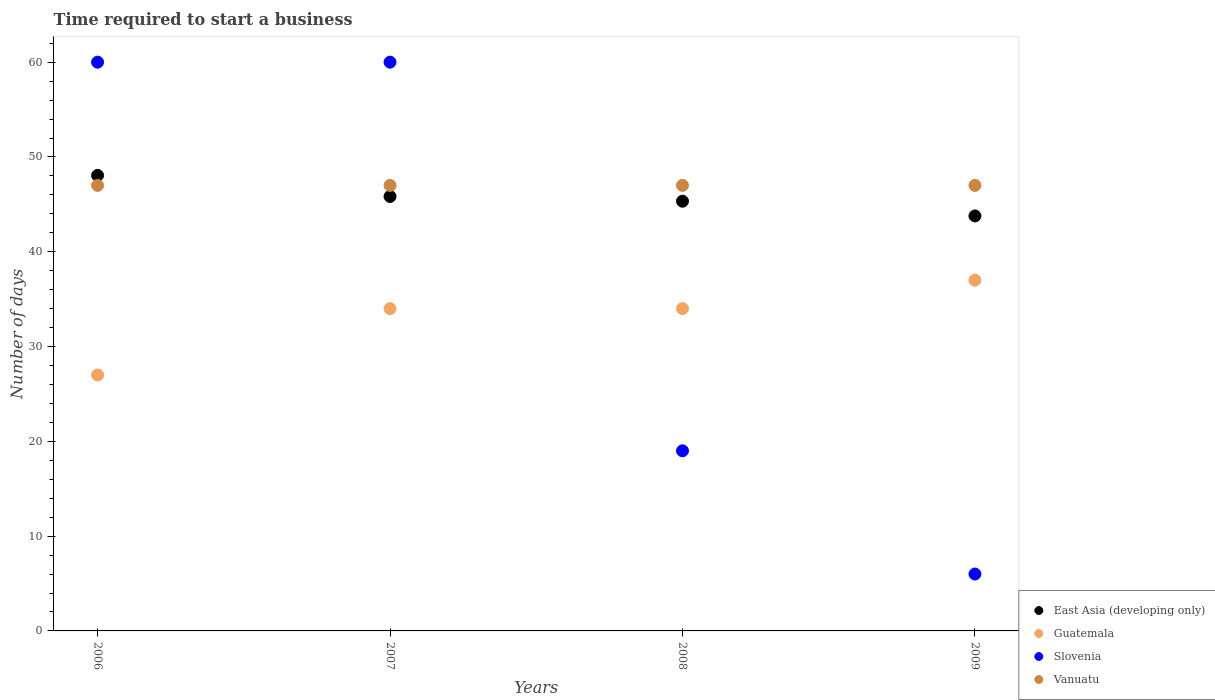Across all years, what is the maximum number of days required to start a business in East Asia (developing only)?
Provide a succinct answer. 48.06. Across all years, what is the minimum number of days required to start a business in East Asia (developing only)?
Provide a succinct answer. 43.78. In which year was the number of days required to start a business in East Asia (developing only) maximum?
Make the answer very short. 2006. What is the total number of days required to start a business in Slovenia in the graph?
Make the answer very short. 145. What is the difference between the number of days required to start a business in Vanuatu in 2006 and the number of days required to start a business in East Asia (developing only) in 2008?
Ensure brevity in your answer.  1.67. In the year 2007, what is the difference between the number of days required to start a business in East Asia (developing only) and number of days required to start a business in Vanuatu?
Make the answer very short. -1.17. What is the ratio of the number of days required to start a business in Slovenia in 2007 to that in 2008?
Your response must be concise. 3.16. Is the number of days required to start a business in Guatemala in 2006 less than that in 2007?
Your answer should be very brief. Yes. What is the difference between the highest and the second highest number of days required to start a business in East Asia (developing only)?
Make the answer very short. 2.22. In how many years, is the number of days required to start a business in Vanuatu greater than the average number of days required to start a business in Vanuatu taken over all years?
Offer a very short reply. 0. Is the sum of the number of days required to start a business in Guatemala in 2007 and 2008 greater than the maximum number of days required to start a business in East Asia (developing only) across all years?
Offer a terse response. Yes. Is it the case that in every year, the sum of the number of days required to start a business in Slovenia and number of days required to start a business in Vanuatu  is greater than the number of days required to start a business in East Asia (developing only)?
Your response must be concise. Yes. How many dotlines are there?
Keep it short and to the point. 4. Are the values on the major ticks of Y-axis written in scientific E-notation?
Provide a short and direct response. No. Does the graph contain any zero values?
Give a very brief answer. No. Where does the legend appear in the graph?
Keep it short and to the point. Bottom right. How many legend labels are there?
Offer a very short reply. 4. How are the legend labels stacked?
Your answer should be compact. Vertical. What is the title of the graph?
Offer a terse response. Time required to start a business. What is the label or title of the X-axis?
Ensure brevity in your answer.  Years. What is the label or title of the Y-axis?
Offer a terse response. Number of days. What is the Number of days in East Asia (developing only) in 2006?
Your answer should be very brief. 48.06. What is the Number of days in Slovenia in 2006?
Your answer should be very brief. 60. What is the Number of days in East Asia (developing only) in 2007?
Provide a short and direct response. 45.83. What is the Number of days of Vanuatu in 2007?
Your answer should be very brief. 47. What is the Number of days in East Asia (developing only) in 2008?
Your answer should be very brief. 45.33. What is the Number of days of Vanuatu in 2008?
Your answer should be compact. 47. What is the Number of days of East Asia (developing only) in 2009?
Offer a very short reply. 43.78. What is the Number of days of Guatemala in 2009?
Your answer should be compact. 37. What is the Number of days in Vanuatu in 2009?
Give a very brief answer. 47. Across all years, what is the maximum Number of days of East Asia (developing only)?
Ensure brevity in your answer.  48.06. Across all years, what is the maximum Number of days in Guatemala?
Provide a succinct answer. 37. Across all years, what is the maximum Number of days in Slovenia?
Offer a terse response. 60. Across all years, what is the minimum Number of days in East Asia (developing only)?
Your answer should be compact. 43.78. Across all years, what is the minimum Number of days in Slovenia?
Offer a terse response. 6. What is the total Number of days in East Asia (developing only) in the graph?
Keep it short and to the point. 183. What is the total Number of days of Guatemala in the graph?
Ensure brevity in your answer.  132. What is the total Number of days in Slovenia in the graph?
Keep it short and to the point. 145. What is the total Number of days of Vanuatu in the graph?
Your answer should be compact. 188. What is the difference between the Number of days in East Asia (developing only) in 2006 and that in 2007?
Offer a terse response. 2.22. What is the difference between the Number of days of Guatemala in 2006 and that in 2007?
Keep it short and to the point. -7. What is the difference between the Number of days of Slovenia in 2006 and that in 2007?
Make the answer very short. 0. What is the difference between the Number of days in East Asia (developing only) in 2006 and that in 2008?
Offer a very short reply. 2.72. What is the difference between the Number of days in Guatemala in 2006 and that in 2008?
Offer a terse response. -7. What is the difference between the Number of days in Vanuatu in 2006 and that in 2008?
Your answer should be compact. 0. What is the difference between the Number of days of East Asia (developing only) in 2006 and that in 2009?
Give a very brief answer. 4.28. What is the difference between the Number of days of Guatemala in 2006 and that in 2009?
Provide a succinct answer. -10. What is the difference between the Number of days of East Asia (developing only) in 2007 and that in 2008?
Ensure brevity in your answer.  0.5. What is the difference between the Number of days of East Asia (developing only) in 2007 and that in 2009?
Offer a very short reply. 2.06. What is the difference between the Number of days in Guatemala in 2007 and that in 2009?
Offer a very short reply. -3. What is the difference between the Number of days in East Asia (developing only) in 2008 and that in 2009?
Offer a terse response. 1.56. What is the difference between the Number of days in Guatemala in 2008 and that in 2009?
Offer a terse response. -3. What is the difference between the Number of days in Slovenia in 2008 and that in 2009?
Offer a terse response. 13. What is the difference between the Number of days of East Asia (developing only) in 2006 and the Number of days of Guatemala in 2007?
Provide a short and direct response. 14.06. What is the difference between the Number of days in East Asia (developing only) in 2006 and the Number of days in Slovenia in 2007?
Provide a short and direct response. -11.94. What is the difference between the Number of days of East Asia (developing only) in 2006 and the Number of days of Vanuatu in 2007?
Keep it short and to the point. 1.06. What is the difference between the Number of days in Guatemala in 2006 and the Number of days in Slovenia in 2007?
Give a very brief answer. -33. What is the difference between the Number of days in Guatemala in 2006 and the Number of days in Vanuatu in 2007?
Make the answer very short. -20. What is the difference between the Number of days in East Asia (developing only) in 2006 and the Number of days in Guatemala in 2008?
Give a very brief answer. 14.06. What is the difference between the Number of days of East Asia (developing only) in 2006 and the Number of days of Slovenia in 2008?
Make the answer very short. 29.06. What is the difference between the Number of days of East Asia (developing only) in 2006 and the Number of days of Vanuatu in 2008?
Offer a very short reply. 1.06. What is the difference between the Number of days in Guatemala in 2006 and the Number of days in Slovenia in 2008?
Offer a very short reply. 8. What is the difference between the Number of days in Slovenia in 2006 and the Number of days in Vanuatu in 2008?
Your answer should be very brief. 13. What is the difference between the Number of days in East Asia (developing only) in 2006 and the Number of days in Guatemala in 2009?
Your answer should be very brief. 11.06. What is the difference between the Number of days in East Asia (developing only) in 2006 and the Number of days in Slovenia in 2009?
Your response must be concise. 42.06. What is the difference between the Number of days in East Asia (developing only) in 2006 and the Number of days in Vanuatu in 2009?
Your response must be concise. 1.06. What is the difference between the Number of days in Guatemala in 2006 and the Number of days in Vanuatu in 2009?
Provide a short and direct response. -20. What is the difference between the Number of days in East Asia (developing only) in 2007 and the Number of days in Guatemala in 2008?
Your answer should be compact. 11.83. What is the difference between the Number of days of East Asia (developing only) in 2007 and the Number of days of Slovenia in 2008?
Make the answer very short. 26.83. What is the difference between the Number of days in East Asia (developing only) in 2007 and the Number of days in Vanuatu in 2008?
Make the answer very short. -1.17. What is the difference between the Number of days of Guatemala in 2007 and the Number of days of Vanuatu in 2008?
Provide a short and direct response. -13. What is the difference between the Number of days in Slovenia in 2007 and the Number of days in Vanuatu in 2008?
Your answer should be compact. 13. What is the difference between the Number of days in East Asia (developing only) in 2007 and the Number of days in Guatemala in 2009?
Offer a very short reply. 8.83. What is the difference between the Number of days in East Asia (developing only) in 2007 and the Number of days in Slovenia in 2009?
Offer a very short reply. 39.83. What is the difference between the Number of days in East Asia (developing only) in 2007 and the Number of days in Vanuatu in 2009?
Your response must be concise. -1.17. What is the difference between the Number of days in Guatemala in 2007 and the Number of days in Vanuatu in 2009?
Give a very brief answer. -13. What is the difference between the Number of days in Slovenia in 2007 and the Number of days in Vanuatu in 2009?
Offer a very short reply. 13. What is the difference between the Number of days of East Asia (developing only) in 2008 and the Number of days of Guatemala in 2009?
Make the answer very short. 8.33. What is the difference between the Number of days in East Asia (developing only) in 2008 and the Number of days in Slovenia in 2009?
Keep it short and to the point. 39.33. What is the difference between the Number of days in East Asia (developing only) in 2008 and the Number of days in Vanuatu in 2009?
Offer a very short reply. -1.67. What is the difference between the Number of days in Guatemala in 2008 and the Number of days in Slovenia in 2009?
Give a very brief answer. 28. What is the difference between the Number of days in Guatemala in 2008 and the Number of days in Vanuatu in 2009?
Give a very brief answer. -13. What is the average Number of days in East Asia (developing only) per year?
Your answer should be compact. 45.75. What is the average Number of days in Guatemala per year?
Provide a succinct answer. 33. What is the average Number of days in Slovenia per year?
Provide a succinct answer. 36.25. What is the average Number of days in Vanuatu per year?
Your answer should be compact. 47. In the year 2006, what is the difference between the Number of days of East Asia (developing only) and Number of days of Guatemala?
Provide a short and direct response. 21.06. In the year 2006, what is the difference between the Number of days in East Asia (developing only) and Number of days in Slovenia?
Offer a terse response. -11.94. In the year 2006, what is the difference between the Number of days of East Asia (developing only) and Number of days of Vanuatu?
Ensure brevity in your answer.  1.06. In the year 2006, what is the difference between the Number of days in Guatemala and Number of days in Slovenia?
Ensure brevity in your answer.  -33. In the year 2006, what is the difference between the Number of days of Guatemala and Number of days of Vanuatu?
Keep it short and to the point. -20. In the year 2006, what is the difference between the Number of days in Slovenia and Number of days in Vanuatu?
Make the answer very short. 13. In the year 2007, what is the difference between the Number of days of East Asia (developing only) and Number of days of Guatemala?
Your answer should be compact. 11.83. In the year 2007, what is the difference between the Number of days of East Asia (developing only) and Number of days of Slovenia?
Offer a terse response. -14.17. In the year 2007, what is the difference between the Number of days of East Asia (developing only) and Number of days of Vanuatu?
Your answer should be very brief. -1.17. In the year 2007, what is the difference between the Number of days in Slovenia and Number of days in Vanuatu?
Make the answer very short. 13. In the year 2008, what is the difference between the Number of days in East Asia (developing only) and Number of days in Guatemala?
Make the answer very short. 11.33. In the year 2008, what is the difference between the Number of days in East Asia (developing only) and Number of days in Slovenia?
Give a very brief answer. 26.33. In the year 2008, what is the difference between the Number of days of East Asia (developing only) and Number of days of Vanuatu?
Give a very brief answer. -1.67. In the year 2008, what is the difference between the Number of days of Guatemala and Number of days of Vanuatu?
Keep it short and to the point. -13. In the year 2008, what is the difference between the Number of days in Slovenia and Number of days in Vanuatu?
Ensure brevity in your answer.  -28. In the year 2009, what is the difference between the Number of days of East Asia (developing only) and Number of days of Guatemala?
Offer a very short reply. 6.78. In the year 2009, what is the difference between the Number of days in East Asia (developing only) and Number of days in Slovenia?
Give a very brief answer. 37.78. In the year 2009, what is the difference between the Number of days in East Asia (developing only) and Number of days in Vanuatu?
Give a very brief answer. -3.22. In the year 2009, what is the difference between the Number of days of Slovenia and Number of days of Vanuatu?
Give a very brief answer. -41. What is the ratio of the Number of days of East Asia (developing only) in 2006 to that in 2007?
Make the answer very short. 1.05. What is the ratio of the Number of days of Guatemala in 2006 to that in 2007?
Ensure brevity in your answer.  0.79. What is the ratio of the Number of days of Slovenia in 2006 to that in 2007?
Provide a short and direct response. 1. What is the ratio of the Number of days in Vanuatu in 2006 to that in 2007?
Provide a short and direct response. 1. What is the ratio of the Number of days in East Asia (developing only) in 2006 to that in 2008?
Your answer should be very brief. 1.06. What is the ratio of the Number of days of Guatemala in 2006 to that in 2008?
Your response must be concise. 0.79. What is the ratio of the Number of days in Slovenia in 2006 to that in 2008?
Offer a very short reply. 3.16. What is the ratio of the Number of days of Vanuatu in 2006 to that in 2008?
Ensure brevity in your answer.  1. What is the ratio of the Number of days in East Asia (developing only) in 2006 to that in 2009?
Offer a terse response. 1.1. What is the ratio of the Number of days in Guatemala in 2006 to that in 2009?
Keep it short and to the point. 0.73. What is the ratio of the Number of days in Vanuatu in 2006 to that in 2009?
Your answer should be compact. 1. What is the ratio of the Number of days of Guatemala in 2007 to that in 2008?
Offer a terse response. 1. What is the ratio of the Number of days in Slovenia in 2007 to that in 2008?
Provide a succinct answer. 3.16. What is the ratio of the Number of days in Vanuatu in 2007 to that in 2008?
Provide a succinct answer. 1. What is the ratio of the Number of days of East Asia (developing only) in 2007 to that in 2009?
Your answer should be very brief. 1.05. What is the ratio of the Number of days of Guatemala in 2007 to that in 2009?
Make the answer very short. 0.92. What is the ratio of the Number of days of Slovenia in 2007 to that in 2009?
Make the answer very short. 10. What is the ratio of the Number of days of Vanuatu in 2007 to that in 2009?
Your response must be concise. 1. What is the ratio of the Number of days of East Asia (developing only) in 2008 to that in 2009?
Offer a terse response. 1.04. What is the ratio of the Number of days in Guatemala in 2008 to that in 2009?
Ensure brevity in your answer.  0.92. What is the ratio of the Number of days of Slovenia in 2008 to that in 2009?
Provide a short and direct response. 3.17. What is the ratio of the Number of days of Vanuatu in 2008 to that in 2009?
Your response must be concise. 1. What is the difference between the highest and the second highest Number of days in East Asia (developing only)?
Make the answer very short. 2.22. What is the difference between the highest and the second highest Number of days of Slovenia?
Offer a terse response. 0. What is the difference between the highest and the second highest Number of days of Vanuatu?
Offer a very short reply. 0. What is the difference between the highest and the lowest Number of days of East Asia (developing only)?
Offer a terse response. 4.28. What is the difference between the highest and the lowest Number of days in Guatemala?
Ensure brevity in your answer.  10. What is the difference between the highest and the lowest Number of days of Slovenia?
Provide a short and direct response. 54. What is the difference between the highest and the lowest Number of days in Vanuatu?
Keep it short and to the point. 0. 